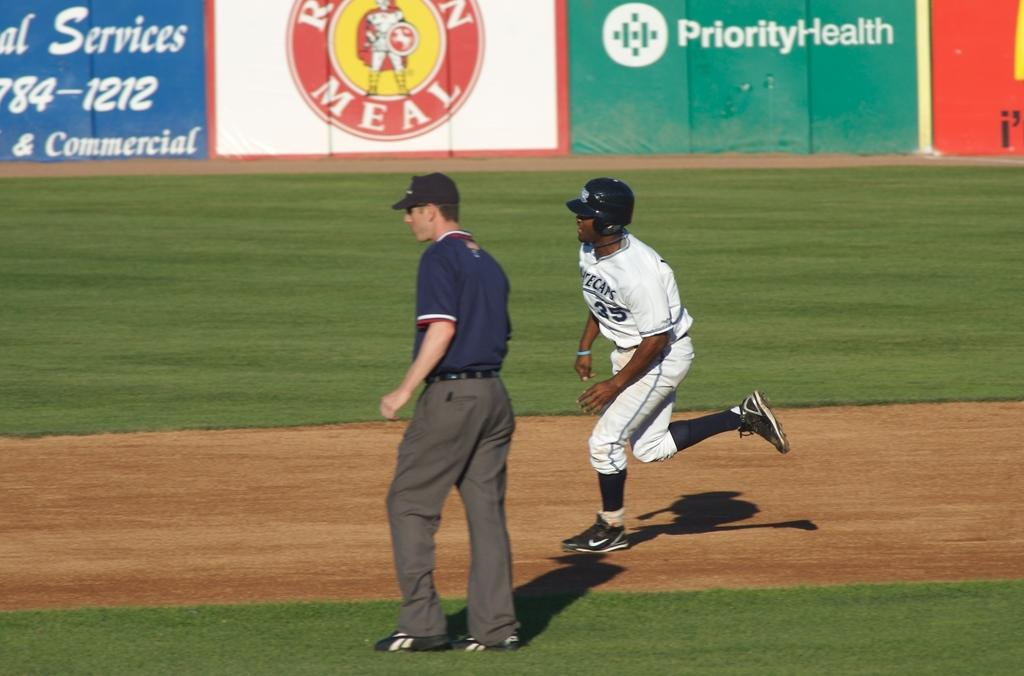Provide a one-sentence caption for the provided image. A baseball player is running by a referee in front of an ad for Priority Health. 